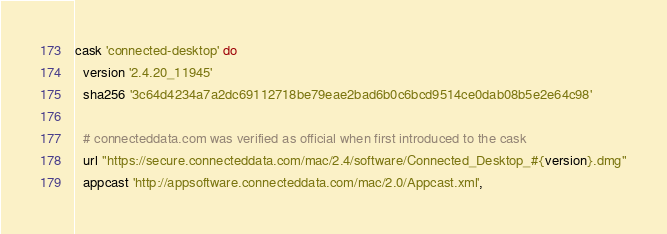Convert code to text. <code><loc_0><loc_0><loc_500><loc_500><_Ruby_>cask 'connected-desktop' do
  version '2.4.20_11945'
  sha256 '3c64d4234a7a2dc69112718be79eae2bad6b0c6bcd9514ce0dab08b5e2e64c98'

  # connecteddata.com was verified as official when first introduced to the cask
  url "https://secure.connecteddata.com/mac/2.4/software/Connected_Desktop_#{version}.dmg"
  appcast 'http://appsoftware.connecteddata.com/mac/2.0/Appcast.xml',</code> 